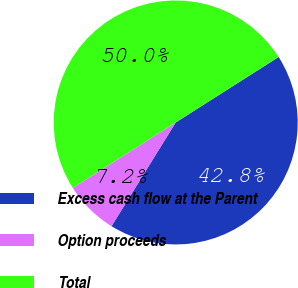<chart> <loc_0><loc_0><loc_500><loc_500><pie_chart><fcel>Excess cash flow at the Parent<fcel>Option proceeds<fcel>Total<nl><fcel>42.84%<fcel>7.16%<fcel>50.0%<nl></chart> 